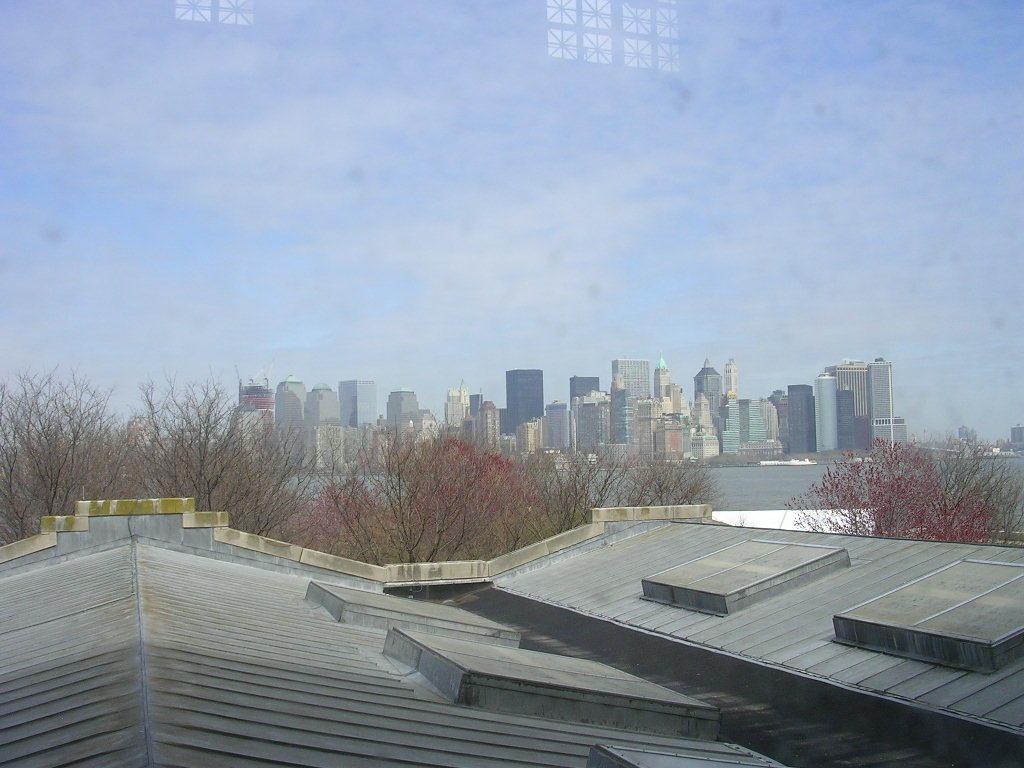How would you summarize this image in a sentence or two? In this image we can see buildings, trees, water, skyscrapers and sky. 